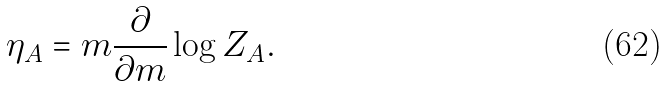Convert formula to latex. <formula><loc_0><loc_0><loc_500><loc_500>\eta _ { A } = m \frac { \partial } { \partial m } \log Z _ { A } .</formula> 